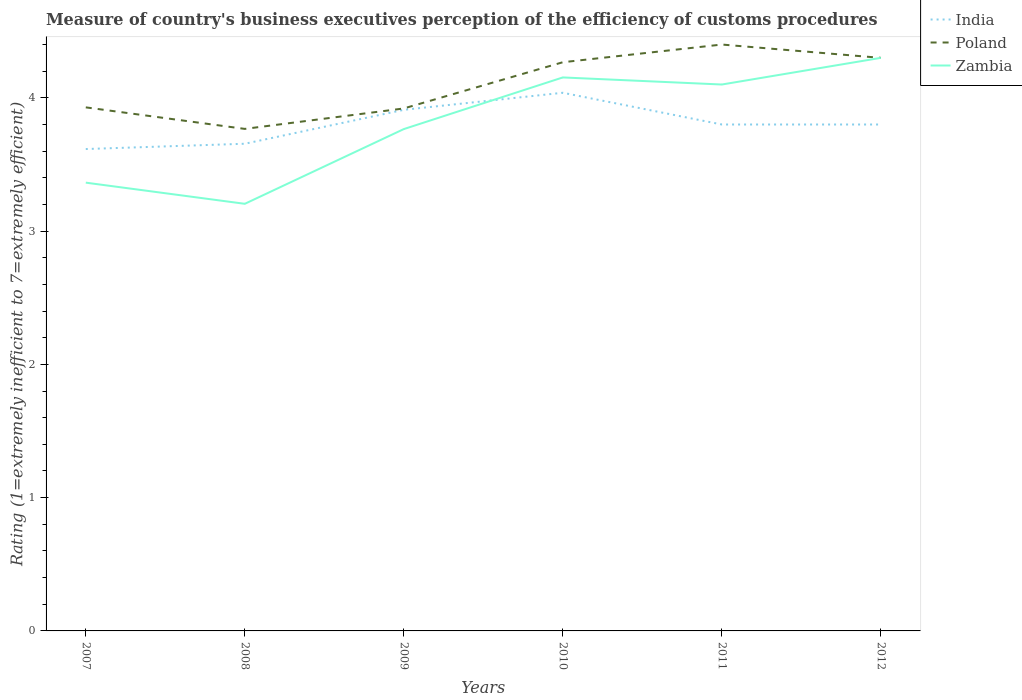How many different coloured lines are there?
Your response must be concise. 3. Does the line corresponding to Poland intersect with the line corresponding to India?
Offer a terse response. No. Across all years, what is the maximum rating of the efficiency of customs procedure in Poland?
Keep it short and to the point. 3.77. In which year was the rating of the efficiency of customs procedure in Poland maximum?
Your answer should be very brief. 2008. What is the total rating of the efficiency of customs procedure in India in the graph?
Ensure brevity in your answer.  0. What is the difference between the highest and the second highest rating of the efficiency of customs procedure in Poland?
Provide a succinct answer. 0.63. What is the difference between the highest and the lowest rating of the efficiency of customs procedure in Zambia?
Give a very brief answer. 3. Is the rating of the efficiency of customs procedure in Poland strictly greater than the rating of the efficiency of customs procedure in India over the years?
Your answer should be compact. No. How many lines are there?
Offer a very short reply. 3. Are the values on the major ticks of Y-axis written in scientific E-notation?
Provide a succinct answer. No. Does the graph contain grids?
Offer a terse response. No. How many legend labels are there?
Your answer should be compact. 3. How are the legend labels stacked?
Provide a short and direct response. Vertical. What is the title of the graph?
Make the answer very short. Measure of country's business executives perception of the efficiency of customs procedures. Does "Lithuania" appear as one of the legend labels in the graph?
Ensure brevity in your answer.  No. What is the label or title of the Y-axis?
Give a very brief answer. Rating (1=extremely inefficient to 7=extremely efficient). What is the Rating (1=extremely inefficient to 7=extremely efficient) of India in 2007?
Give a very brief answer. 3.62. What is the Rating (1=extremely inefficient to 7=extremely efficient) of Poland in 2007?
Your response must be concise. 3.93. What is the Rating (1=extremely inefficient to 7=extremely efficient) of Zambia in 2007?
Your response must be concise. 3.36. What is the Rating (1=extremely inefficient to 7=extremely efficient) in India in 2008?
Your response must be concise. 3.66. What is the Rating (1=extremely inefficient to 7=extremely efficient) of Poland in 2008?
Ensure brevity in your answer.  3.77. What is the Rating (1=extremely inefficient to 7=extremely efficient) of Zambia in 2008?
Provide a short and direct response. 3.2. What is the Rating (1=extremely inefficient to 7=extremely efficient) of India in 2009?
Offer a terse response. 3.91. What is the Rating (1=extremely inefficient to 7=extremely efficient) of Poland in 2009?
Your answer should be very brief. 3.92. What is the Rating (1=extremely inefficient to 7=extremely efficient) in Zambia in 2009?
Provide a short and direct response. 3.77. What is the Rating (1=extremely inefficient to 7=extremely efficient) in India in 2010?
Provide a short and direct response. 4.04. What is the Rating (1=extremely inefficient to 7=extremely efficient) in Poland in 2010?
Offer a terse response. 4.27. What is the Rating (1=extremely inefficient to 7=extremely efficient) of Zambia in 2010?
Give a very brief answer. 4.15. What is the Rating (1=extremely inefficient to 7=extremely efficient) in India in 2011?
Provide a succinct answer. 3.8. What is the Rating (1=extremely inefficient to 7=extremely efficient) in India in 2012?
Ensure brevity in your answer.  3.8. What is the Rating (1=extremely inefficient to 7=extremely efficient) in Poland in 2012?
Keep it short and to the point. 4.3. Across all years, what is the maximum Rating (1=extremely inefficient to 7=extremely efficient) in India?
Ensure brevity in your answer.  4.04. Across all years, what is the minimum Rating (1=extremely inefficient to 7=extremely efficient) in India?
Provide a short and direct response. 3.62. Across all years, what is the minimum Rating (1=extremely inefficient to 7=extremely efficient) of Poland?
Your answer should be compact. 3.77. Across all years, what is the minimum Rating (1=extremely inefficient to 7=extremely efficient) in Zambia?
Offer a terse response. 3.2. What is the total Rating (1=extremely inefficient to 7=extremely efficient) of India in the graph?
Give a very brief answer. 22.82. What is the total Rating (1=extremely inefficient to 7=extremely efficient) of Poland in the graph?
Offer a very short reply. 24.58. What is the total Rating (1=extremely inefficient to 7=extremely efficient) in Zambia in the graph?
Offer a terse response. 22.89. What is the difference between the Rating (1=extremely inefficient to 7=extremely efficient) of India in 2007 and that in 2008?
Keep it short and to the point. -0.04. What is the difference between the Rating (1=extremely inefficient to 7=extremely efficient) of Poland in 2007 and that in 2008?
Your response must be concise. 0.16. What is the difference between the Rating (1=extremely inefficient to 7=extremely efficient) of Zambia in 2007 and that in 2008?
Your answer should be very brief. 0.16. What is the difference between the Rating (1=extremely inefficient to 7=extremely efficient) of India in 2007 and that in 2009?
Your response must be concise. -0.29. What is the difference between the Rating (1=extremely inefficient to 7=extremely efficient) in Poland in 2007 and that in 2009?
Provide a succinct answer. 0.01. What is the difference between the Rating (1=extremely inefficient to 7=extremely efficient) in Zambia in 2007 and that in 2009?
Your answer should be compact. -0.4. What is the difference between the Rating (1=extremely inefficient to 7=extremely efficient) in India in 2007 and that in 2010?
Keep it short and to the point. -0.42. What is the difference between the Rating (1=extremely inefficient to 7=extremely efficient) of Poland in 2007 and that in 2010?
Your answer should be compact. -0.34. What is the difference between the Rating (1=extremely inefficient to 7=extremely efficient) of Zambia in 2007 and that in 2010?
Make the answer very short. -0.79. What is the difference between the Rating (1=extremely inefficient to 7=extremely efficient) of India in 2007 and that in 2011?
Offer a very short reply. -0.18. What is the difference between the Rating (1=extremely inefficient to 7=extremely efficient) of Poland in 2007 and that in 2011?
Your answer should be compact. -0.47. What is the difference between the Rating (1=extremely inefficient to 7=extremely efficient) in Zambia in 2007 and that in 2011?
Your response must be concise. -0.74. What is the difference between the Rating (1=extremely inefficient to 7=extremely efficient) of India in 2007 and that in 2012?
Provide a succinct answer. -0.18. What is the difference between the Rating (1=extremely inefficient to 7=extremely efficient) in Poland in 2007 and that in 2012?
Offer a very short reply. -0.37. What is the difference between the Rating (1=extremely inefficient to 7=extremely efficient) in Zambia in 2007 and that in 2012?
Ensure brevity in your answer.  -0.94. What is the difference between the Rating (1=extremely inefficient to 7=extremely efficient) of India in 2008 and that in 2009?
Ensure brevity in your answer.  -0.25. What is the difference between the Rating (1=extremely inefficient to 7=extremely efficient) in Poland in 2008 and that in 2009?
Make the answer very short. -0.15. What is the difference between the Rating (1=extremely inefficient to 7=extremely efficient) of Zambia in 2008 and that in 2009?
Give a very brief answer. -0.56. What is the difference between the Rating (1=extremely inefficient to 7=extremely efficient) in India in 2008 and that in 2010?
Keep it short and to the point. -0.38. What is the difference between the Rating (1=extremely inefficient to 7=extremely efficient) of Poland in 2008 and that in 2010?
Ensure brevity in your answer.  -0.5. What is the difference between the Rating (1=extremely inefficient to 7=extremely efficient) of Zambia in 2008 and that in 2010?
Provide a short and direct response. -0.95. What is the difference between the Rating (1=extremely inefficient to 7=extremely efficient) in India in 2008 and that in 2011?
Provide a short and direct response. -0.14. What is the difference between the Rating (1=extremely inefficient to 7=extremely efficient) of Poland in 2008 and that in 2011?
Ensure brevity in your answer.  -0.63. What is the difference between the Rating (1=extremely inefficient to 7=extremely efficient) in Zambia in 2008 and that in 2011?
Offer a very short reply. -0.9. What is the difference between the Rating (1=extremely inefficient to 7=extremely efficient) in India in 2008 and that in 2012?
Ensure brevity in your answer.  -0.14. What is the difference between the Rating (1=extremely inefficient to 7=extremely efficient) of Poland in 2008 and that in 2012?
Your response must be concise. -0.53. What is the difference between the Rating (1=extremely inefficient to 7=extremely efficient) in Zambia in 2008 and that in 2012?
Keep it short and to the point. -1.1. What is the difference between the Rating (1=extremely inefficient to 7=extremely efficient) in India in 2009 and that in 2010?
Give a very brief answer. -0.13. What is the difference between the Rating (1=extremely inefficient to 7=extremely efficient) of Poland in 2009 and that in 2010?
Keep it short and to the point. -0.35. What is the difference between the Rating (1=extremely inefficient to 7=extremely efficient) of Zambia in 2009 and that in 2010?
Ensure brevity in your answer.  -0.39. What is the difference between the Rating (1=extremely inefficient to 7=extremely efficient) of India in 2009 and that in 2011?
Provide a short and direct response. 0.11. What is the difference between the Rating (1=extremely inefficient to 7=extremely efficient) in Poland in 2009 and that in 2011?
Ensure brevity in your answer.  -0.48. What is the difference between the Rating (1=extremely inefficient to 7=extremely efficient) in Zambia in 2009 and that in 2011?
Make the answer very short. -0.33. What is the difference between the Rating (1=extremely inefficient to 7=extremely efficient) in India in 2009 and that in 2012?
Your response must be concise. 0.11. What is the difference between the Rating (1=extremely inefficient to 7=extremely efficient) of Poland in 2009 and that in 2012?
Give a very brief answer. -0.38. What is the difference between the Rating (1=extremely inefficient to 7=extremely efficient) of Zambia in 2009 and that in 2012?
Give a very brief answer. -0.53. What is the difference between the Rating (1=extremely inefficient to 7=extremely efficient) in India in 2010 and that in 2011?
Offer a terse response. 0.24. What is the difference between the Rating (1=extremely inefficient to 7=extremely efficient) of Poland in 2010 and that in 2011?
Provide a succinct answer. -0.13. What is the difference between the Rating (1=extremely inefficient to 7=extremely efficient) of Zambia in 2010 and that in 2011?
Provide a succinct answer. 0.05. What is the difference between the Rating (1=extremely inefficient to 7=extremely efficient) in India in 2010 and that in 2012?
Offer a terse response. 0.24. What is the difference between the Rating (1=extremely inefficient to 7=extremely efficient) of Poland in 2010 and that in 2012?
Provide a succinct answer. -0.03. What is the difference between the Rating (1=extremely inefficient to 7=extremely efficient) in Zambia in 2010 and that in 2012?
Your answer should be compact. -0.15. What is the difference between the Rating (1=extremely inefficient to 7=extremely efficient) of Poland in 2011 and that in 2012?
Provide a short and direct response. 0.1. What is the difference between the Rating (1=extremely inefficient to 7=extremely efficient) of Zambia in 2011 and that in 2012?
Make the answer very short. -0.2. What is the difference between the Rating (1=extremely inefficient to 7=extremely efficient) of India in 2007 and the Rating (1=extremely inefficient to 7=extremely efficient) of Poland in 2008?
Your response must be concise. -0.15. What is the difference between the Rating (1=extremely inefficient to 7=extremely efficient) of India in 2007 and the Rating (1=extremely inefficient to 7=extremely efficient) of Zambia in 2008?
Give a very brief answer. 0.41. What is the difference between the Rating (1=extremely inefficient to 7=extremely efficient) of Poland in 2007 and the Rating (1=extremely inefficient to 7=extremely efficient) of Zambia in 2008?
Your response must be concise. 0.72. What is the difference between the Rating (1=extremely inefficient to 7=extremely efficient) in India in 2007 and the Rating (1=extremely inefficient to 7=extremely efficient) in Poland in 2009?
Give a very brief answer. -0.3. What is the difference between the Rating (1=extremely inefficient to 7=extremely efficient) in India in 2007 and the Rating (1=extremely inefficient to 7=extremely efficient) in Zambia in 2009?
Your answer should be compact. -0.15. What is the difference between the Rating (1=extremely inefficient to 7=extremely efficient) in Poland in 2007 and the Rating (1=extremely inefficient to 7=extremely efficient) in Zambia in 2009?
Make the answer very short. 0.16. What is the difference between the Rating (1=extremely inefficient to 7=extremely efficient) in India in 2007 and the Rating (1=extremely inefficient to 7=extremely efficient) in Poland in 2010?
Offer a terse response. -0.65. What is the difference between the Rating (1=extremely inefficient to 7=extremely efficient) of India in 2007 and the Rating (1=extremely inefficient to 7=extremely efficient) of Zambia in 2010?
Ensure brevity in your answer.  -0.54. What is the difference between the Rating (1=extremely inefficient to 7=extremely efficient) of Poland in 2007 and the Rating (1=extremely inefficient to 7=extremely efficient) of Zambia in 2010?
Give a very brief answer. -0.22. What is the difference between the Rating (1=extremely inefficient to 7=extremely efficient) in India in 2007 and the Rating (1=extremely inefficient to 7=extremely efficient) in Poland in 2011?
Ensure brevity in your answer.  -0.78. What is the difference between the Rating (1=extremely inefficient to 7=extremely efficient) in India in 2007 and the Rating (1=extremely inefficient to 7=extremely efficient) in Zambia in 2011?
Make the answer very short. -0.48. What is the difference between the Rating (1=extremely inefficient to 7=extremely efficient) of Poland in 2007 and the Rating (1=extremely inefficient to 7=extremely efficient) of Zambia in 2011?
Your answer should be very brief. -0.17. What is the difference between the Rating (1=extremely inefficient to 7=extremely efficient) of India in 2007 and the Rating (1=extremely inefficient to 7=extremely efficient) of Poland in 2012?
Your response must be concise. -0.68. What is the difference between the Rating (1=extremely inefficient to 7=extremely efficient) in India in 2007 and the Rating (1=extremely inefficient to 7=extremely efficient) in Zambia in 2012?
Your answer should be very brief. -0.68. What is the difference between the Rating (1=extremely inefficient to 7=extremely efficient) of Poland in 2007 and the Rating (1=extremely inefficient to 7=extremely efficient) of Zambia in 2012?
Ensure brevity in your answer.  -0.37. What is the difference between the Rating (1=extremely inefficient to 7=extremely efficient) in India in 2008 and the Rating (1=extremely inefficient to 7=extremely efficient) in Poland in 2009?
Provide a short and direct response. -0.26. What is the difference between the Rating (1=extremely inefficient to 7=extremely efficient) in India in 2008 and the Rating (1=extremely inefficient to 7=extremely efficient) in Zambia in 2009?
Offer a very short reply. -0.11. What is the difference between the Rating (1=extremely inefficient to 7=extremely efficient) in Poland in 2008 and the Rating (1=extremely inefficient to 7=extremely efficient) in Zambia in 2009?
Your answer should be compact. 0. What is the difference between the Rating (1=extremely inefficient to 7=extremely efficient) in India in 2008 and the Rating (1=extremely inefficient to 7=extremely efficient) in Poland in 2010?
Make the answer very short. -0.61. What is the difference between the Rating (1=extremely inefficient to 7=extremely efficient) in India in 2008 and the Rating (1=extremely inefficient to 7=extremely efficient) in Zambia in 2010?
Offer a very short reply. -0.5. What is the difference between the Rating (1=extremely inefficient to 7=extremely efficient) in Poland in 2008 and the Rating (1=extremely inefficient to 7=extremely efficient) in Zambia in 2010?
Ensure brevity in your answer.  -0.39. What is the difference between the Rating (1=extremely inefficient to 7=extremely efficient) in India in 2008 and the Rating (1=extremely inefficient to 7=extremely efficient) in Poland in 2011?
Give a very brief answer. -0.74. What is the difference between the Rating (1=extremely inefficient to 7=extremely efficient) in India in 2008 and the Rating (1=extremely inefficient to 7=extremely efficient) in Zambia in 2011?
Offer a terse response. -0.44. What is the difference between the Rating (1=extremely inefficient to 7=extremely efficient) of Poland in 2008 and the Rating (1=extremely inefficient to 7=extremely efficient) of Zambia in 2011?
Offer a very short reply. -0.33. What is the difference between the Rating (1=extremely inefficient to 7=extremely efficient) in India in 2008 and the Rating (1=extremely inefficient to 7=extremely efficient) in Poland in 2012?
Your response must be concise. -0.64. What is the difference between the Rating (1=extremely inefficient to 7=extremely efficient) in India in 2008 and the Rating (1=extremely inefficient to 7=extremely efficient) in Zambia in 2012?
Provide a short and direct response. -0.64. What is the difference between the Rating (1=extremely inefficient to 7=extremely efficient) in Poland in 2008 and the Rating (1=extremely inefficient to 7=extremely efficient) in Zambia in 2012?
Your response must be concise. -0.53. What is the difference between the Rating (1=extremely inefficient to 7=extremely efficient) of India in 2009 and the Rating (1=extremely inefficient to 7=extremely efficient) of Poland in 2010?
Provide a succinct answer. -0.36. What is the difference between the Rating (1=extremely inefficient to 7=extremely efficient) of India in 2009 and the Rating (1=extremely inefficient to 7=extremely efficient) of Zambia in 2010?
Provide a succinct answer. -0.24. What is the difference between the Rating (1=extremely inefficient to 7=extremely efficient) in Poland in 2009 and the Rating (1=extremely inefficient to 7=extremely efficient) in Zambia in 2010?
Make the answer very short. -0.23. What is the difference between the Rating (1=extremely inefficient to 7=extremely efficient) of India in 2009 and the Rating (1=extremely inefficient to 7=extremely efficient) of Poland in 2011?
Give a very brief answer. -0.49. What is the difference between the Rating (1=extremely inefficient to 7=extremely efficient) of India in 2009 and the Rating (1=extremely inefficient to 7=extremely efficient) of Zambia in 2011?
Keep it short and to the point. -0.19. What is the difference between the Rating (1=extremely inefficient to 7=extremely efficient) of Poland in 2009 and the Rating (1=extremely inefficient to 7=extremely efficient) of Zambia in 2011?
Your response must be concise. -0.18. What is the difference between the Rating (1=extremely inefficient to 7=extremely efficient) in India in 2009 and the Rating (1=extremely inefficient to 7=extremely efficient) in Poland in 2012?
Provide a succinct answer. -0.39. What is the difference between the Rating (1=extremely inefficient to 7=extremely efficient) of India in 2009 and the Rating (1=extremely inefficient to 7=extremely efficient) of Zambia in 2012?
Provide a succinct answer. -0.39. What is the difference between the Rating (1=extremely inefficient to 7=extremely efficient) in Poland in 2009 and the Rating (1=extremely inefficient to 7=extremely efficient) in Zambia in 2012?
Your response must be concise. -0.38. What is the difference between the Rating (1=extremely inefficient to 7=extremely efficient) of India in 2010 and the Rating (1=extremely inefficient to 7=extremely efficient) of Poland in 2011?
Make the answer very short. -0.36. What is the difference between the Rating (1=extremely inefficient to 7=extremely efficient) in India in 2010 and the Rating (1=extremely inefficient to 7=extremely efficient) in Zambia in 2011?
Make the answer very short. -0.06. What is the difference between the Rating (1=extremely inefficient to 7=extremely efficient) in Poland in 2010 and the Rating (1=extremely inefficient to 7=extremely efficient) in Zambia in 2011?
Keep it short and to the point. 0.17. What is the difference between the Rating (1=extremely inefficient to 7=extremely efficient) of India in 2010 and the Rating (1=extremely inefficient to 7=extremely efficient) of Poland in 2012?
Provide a short and direct response. -0.26. What is the difference between the Rating (1=extremely inefficient to 7=extremely efficient) of India in 2010 and the Rating (1=extremely inefficient to 7=extremely efficient) of Zambia in 2012?
Provide a short and direct response. -0.26. What is the difference between the Rating (1=extremely inefficient to 7=extremely efficient) in Poland in 2010 and the Rating (1=extremely inefficient to 7=extremely efficient) in Zambia in 2012?
Ensure brevity in your answer.  -0.03. What is the difference between the Rating (1=extremely inefficient to 7=extremely efficient) in India in 2011 and the Rating (1=extremely inefficient to 7=extremely efficient) in Poland in 2012?
Make the answer very short. -0.5. What is the difference between the Rating (1=extremely inefficient to 7=extremely efficient) of India in 2011 and the Rating (1=extremely inefficient to 7=extremely efficient) of Zambia in 2012?
Ensure brevity in your answer.  -0.5. What is the average Rating (1=extremely inefficient to 7=extremely efficient) in India per year?
Ensure brevity in your answer.  3.8. What is the average Rating (1=extremely inefficient to 7=extremely efficient) in Poland per year?
Your response must be concise. 4.1. What is the average Rating (1=extremely inefficient to 7=extremely efficient) of Zambia per year?
Your response must be concise. 3.81. In the year 2007, what is the difference between the Rating (1=extremely inefficient to 7=extremely efficient) in India and Rating (1=extremely inefficient to 7=extremely efficient) in Poland?
Provide a short and direct response. -0.31. In the year 2007, what is the difference between the Rating (1=extremely inefficient to 7=extremely efficient) of India and Rating (1=extremely inefficient to 7=extremely efficient) of Zambia?
Offer a terse response. 0.25. In the year 2007, what is the difference between the Rating (1=extremely inefficient to 7=extremely efficient) of Poland and Rating (1=extremely inefficient to 7=extremely efficient) of Zambia?
Your answer should be compact. 0.56. In the year 2008, what is the difference between the Rating (1=extremely inefficient to 7=extremely efficient) of India and Rating (1=extremely inefficient to 7=extremely efficient) of Poland?
Make the answer very short. -0.11. In the year 2008, what is the difference between the Rating (1=extremely inefficient to 7=extremely efficient) in India and Rating (1=extremely inefficient to 7=extremely efficient) in Zambia?
Provide a succinct answer. 0.45. In the year 2008, what is the difference between the Rating (1=extremely inefficient to 7=extremely efficient) in Poland and Rating (1=extremely inefficient to 7=extremely efficient) in Zambia?
Provide a succinct answer. 0.56. In the year 2009, what is the difference between the Rating (1=extremely inefficient to 7=extremely efficient) in India and Rating (1=extremely inefficient to 7=extremely efficient) in Poland?
Your answer should be compact. -0.01. In the year 2009, what is the difference between the Rating (1=extremely inefficient to 7=extremely efficient) in India and Rating (1=extremely inefficient to 7=extremely efficient) in Zambia?
Ensure brevity in your answer.  0.14. In the year 2009, what is the difference between the Rating (1=extremely inefficient to 7=extremely efficient) of Poland and Rating (1=extremely inefficient to 7=extremely efficient) of Zambia?
Provide a succinct answer. 0.15. In the year 2010, what is the difference between the Rating (1=extremely inefficient to 7=extremely efficient) in India and Rating (1=extremely inefficient to 7=extremely efficient) in Poland?
Offer a very short reply. -0.23. In the year 2010, what is the difference between the Rating (1=extremely inefficient to 7=extremely efficient) in India and Rating (1=extremely inefficient to 7=extremely efficient) in Zambia?
Your answer should be very brief. -0.12. In the year 2010, what is the difference between the Rating (1=extremely inefficient to 7=extremely efficient) in Poland and Rating (1=extremely inefficient to 7=extremely efficient) in Zambia?
Your answer should be very brief. 0.11. What is the ratio of the Rating (1=extremely inefficient to 7=extremely efficient) of Poland in 2007 to that in 2008?
Keep it short and to the point. 1.04. What is the ratio of the Rating (1=extremely inefficient to 7=extremely efficient) in Zambia in 2007 to that in 2008?
Keep it short and to the point. 1.05. What is the ratio of the Rating (1=extremely inefficient to 7=extremely efficient) in India in 2007 to that in 2009?
Ensure brevity in your answer.  0.92. What is the ratio of the Rating (1=extremely inefficient to 7=extremely efficient) of Zambia in 2007 to that in 2009?
Offer a terse response. 0.89. What is the ratio of the Rating (1=extremely inefficient to 7=extremely efficient) of India in 2007 to that in 2010?
Your response must be concise. 0.9. What is the ratio of the Rating (1=extremely inefficient to 7=extremely efficient) of Poland in 2007 to that in 2010?
Your response must be concise. 0.92. What is the ratio of the Rating (1=extremely inefficient to 7=extremely efficient) in Zambia in 2007 to that in 2010?
Your response must be concise. 0.81. What is the ratio of the Rating (1=extremely inefficient to 7=extremely efficient) of India in 2007 to that in 2011?
Your answer should be very brief. 0.95. What is the ratio of the Rating (1=extremely inefficient to 7=extremely efficient) in Poland in 2007 to that in 2011?
Keep it short and to the point. 0.89. What is the ratio of the Rating (1=extremely inefficient to 7=extremely efficient) in Zambia in 2007 to that in 2011?
Keep it short and to the point. 0.82. What is the ratio of the Rating (1=extremely inefficient to 7=extremely efficient) of India in 2007 to that in 2012?
Give a very brief answer. 0.95. What is the ratio of the Rating (1=extremely inefficient to 7=extremely efficient) of Poland in 2007 to that in 2012?
Your response must be concise. 0.91. What is the ratio of the Rating (1=extremely inefficient to 7=extremely efficient) of Zambia in 2007 to that in 2012?
Ensure brevity in your answer.  0.78. What is the ratio of the Rating (1=extremely inefficient to 7=extremely efficient) in India in 2008 to that in 2009?
Give a very brief answer. 0.93. What is the ratio of the Rating (1=extremely inefficient to 7=extremely efficient) in Poland in 2008 to that in 2009?
Provide a short and direct response. 0.96. What is the ratio of the Rating (1=extremely inefficient to 7=extremely efficient) of Zambia in 2008 to that in 2009?
Keep it short and to the point. 0.85. What is the ratio of the Rating (1=extremely inefficient to 7=extremely efficient) of India in 2008 to that in 2010?
Offer a terse response. 0.91. What is the ratio of the Rating (1=extremely inefficient to 7=extremely efficient) in Poland in 2008 to that in 2010?
Your answer should be very brief. 0.88. What is the ratio of the Rating (1=extremely inefficient to 7=extremely efficient) in Zambia in 2008 to that in 2010?
Your response must be concise. 0.77. What is the ratio of the Rating (1=extremely inefficient to 7=extremely efficient) in India in 2008 to that in 2011?
Your answer should be compact. 0.96. What is the ratio of the Rating (1=extremely inefficient to 7=extremely efficient) in Poland in 2008 to that in 2011?
Offer a very short reply. 0.86. What is the ratio of the Rating (1=extremely inefficient to 7=extremely efficient) in Zambia in 2008 to that in 2011?
Ensure brevity in your answer.  0.78. What is the ratio of the Rating (1=extremely inefficient to 7=extremely efficient) of India in 2008 to that in 2012?
Your response must be concise. 0.96. What is the ratio of the Rating (1=extremely inefficient to 7=extremely efficient) of Poland in 2008 to that in 2012?
Your response must be concise. 0.88. What is the ratio of the Rating (1=extremely inefficient to 7=extremely efficient) in Zambia in 2008 to that in 2012?
Give a very brief answer. 0.75. What is the ratio of the Rating (1=extremely inefficient to 7=extremely efficient) in India in 2009 to that in 2010?
Offer a very short reply. 0.97. What is the ratio of the Rating (1=extremely inefficient to 7=extremely efficient) of Poland in 2009 to that in 2010?
Keep it short and to the point. 0.92. What is the ratio of the Rating (1=extremely inefficient to 7=extremely efficient) of Zambia in 2009 to that in 2010?
Make the answer very short. 0.91. What is the ratio of the Rating (1=extremely inefficient to 7=extremely efficient) in Poland in 2009 to that in 2011?
Your response must be concise. 0.89. What is the ratio of the Rating (1=extremely inefficient to 7=extremely efficient) in Zambia in 2009 to that in 2011?
Give a very brief answer. 0.92. What is the ratio of the Rating (1=extremely inefficient to 7=extremely efficient) in Poland in 2009 to that in 2012?
Provide a short and direct response. 0.91. What is the ratio of the Rating (1=extremely inefficient to 7=extremely efficient) of Zambia in 2009 to that in 2012?
Your answer should be compact. 0.88. What is the ratio of the Rating (1=extremely inefficient to 7=extremely efficient) in India in 2010 to that in 2011?
Your response must be concise. 1.06. What is the ratio of the Rating (1=extremely inefficient to 7=extremely efficient) of Poland in 2010 to that in 2011?
Your answer should be very brief. 0.97. What is the ratio of the Rating (1=extremely inefficient to 7=extremely efficient) of India in 2010 to that in 2012?
Make the answer very short. 1.06. What is the ratio of the Rating (1=extremely inefficient to 7=extremely efficient) of Poland in 2010 to that in 2012?
Offer a terse response. 0.99. What is the ratio of the Rating (1=extremely inefficient to 7=extremely efficient) of Zambia in 2010 to that in 2012?
Your answer should be compact. 0.97. What is the ratio of the Rating (1=extremely inefficient to 7=extremely efficient) of India in 2011 to that in 2012?
Provide a short and direct response. 1. What is the ratio of the Rating (1=extremely inefficient to 7=extremely efficient) of Poland in 2011 to that in 2012?
Your answer should be very brief. 1.02. What is the ratio of the Rating (1=extremely inefficient to 7=extremely efficient) of Zambia in 2011 to that in 2012?
Provide a short and direct response. 0.95. What is the difference between the highest and the second highest Rating (1=extremely inefficient to 7=extremely efficient) in India?
Provide a short and direct response. 0.13. What is the difference between the highest and the second highest Rating (1=extremely inefficient to 7=extremely efficient) of Poland?
Provide a short and direct response. 0.1. What is the difference between the highest and the second highest Rating (1=extremely inefficient to 7=extremely efficient) in Zambia?
Ensure brevity in your answer.  0.15. What is the difference between the highest and the lowest Rating (1=extremely inefficient to 7=extremely efficient) in India?
Your answer should be compact. 0.42. What is the difference between the highest and the lowest Rating (1=extremely inefficient to 7=extremely efficient) in Poland?
Ensure brevity in your answer.  0.63. What is the difference between the highest and the lowest Rating (1=extremely inefficient to 7=extremely efficient) in Zambia?
Keep it short and to the point. 1.1. 